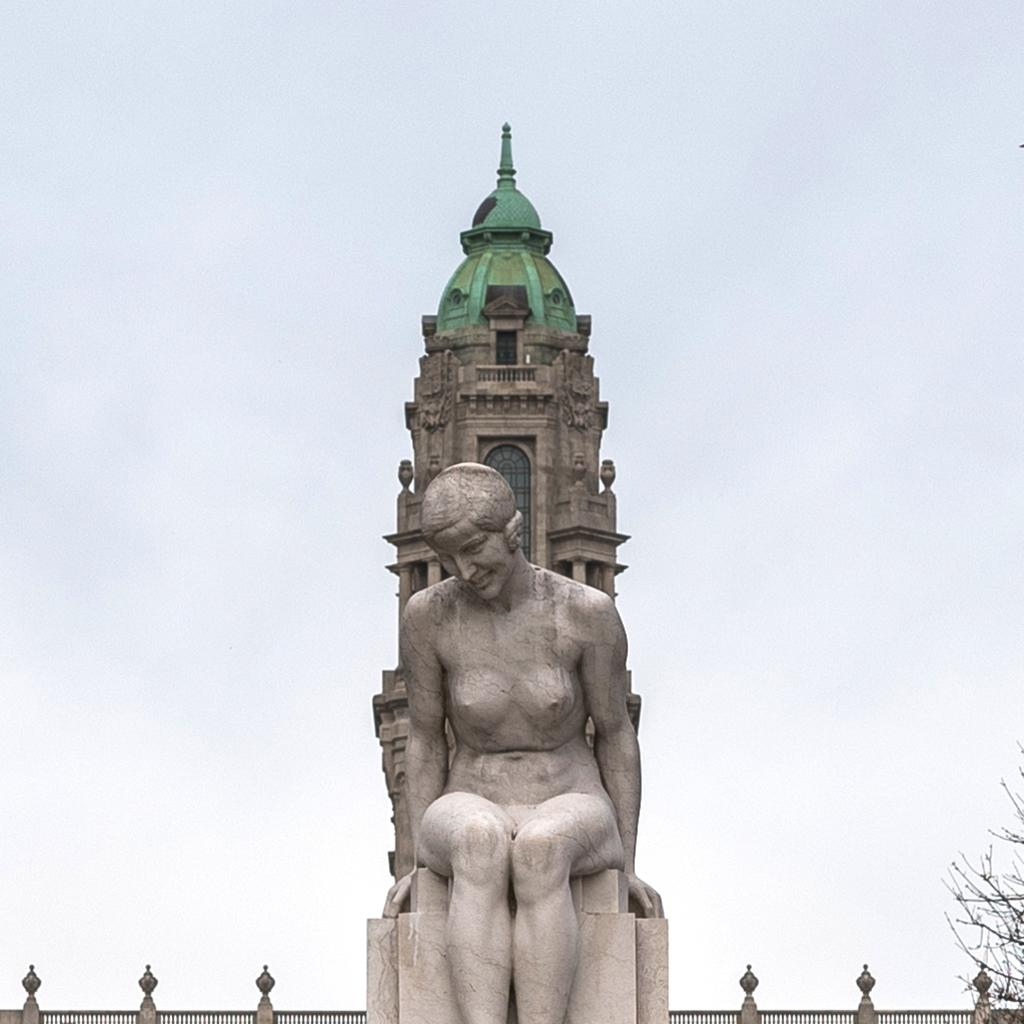What is the main subject in the center of the image? There is a sculpture in the center of the image. What can be seen in the background of the image? There is a tower and a tree in the background of the image. What feature is present that might be used for safety or support? Railings are visible in the image. What is visible at the top of the image? The sky is visible at the top of the image. What type of loaf is being discovered in the image? There is no loaf present in the image, and no discovery is taking place. 